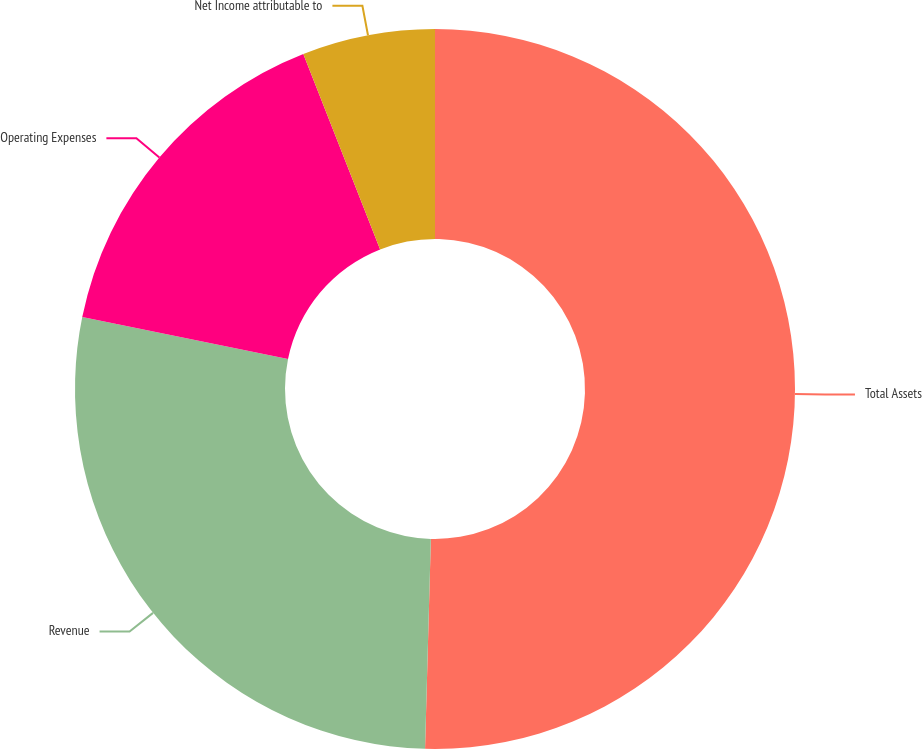Convert chart to OTSL. <chart><loc_0><loc_0><loc_500><loc_500><pie_chart><fcel>Total Assets<fcel>Revenue<fcel>Operating Expenses<fcel>Net Income attributable to<nl><fcel>50.44%<fcel>27.76%<fcel>15.84%<fcel>5.96%<nl></chart> 